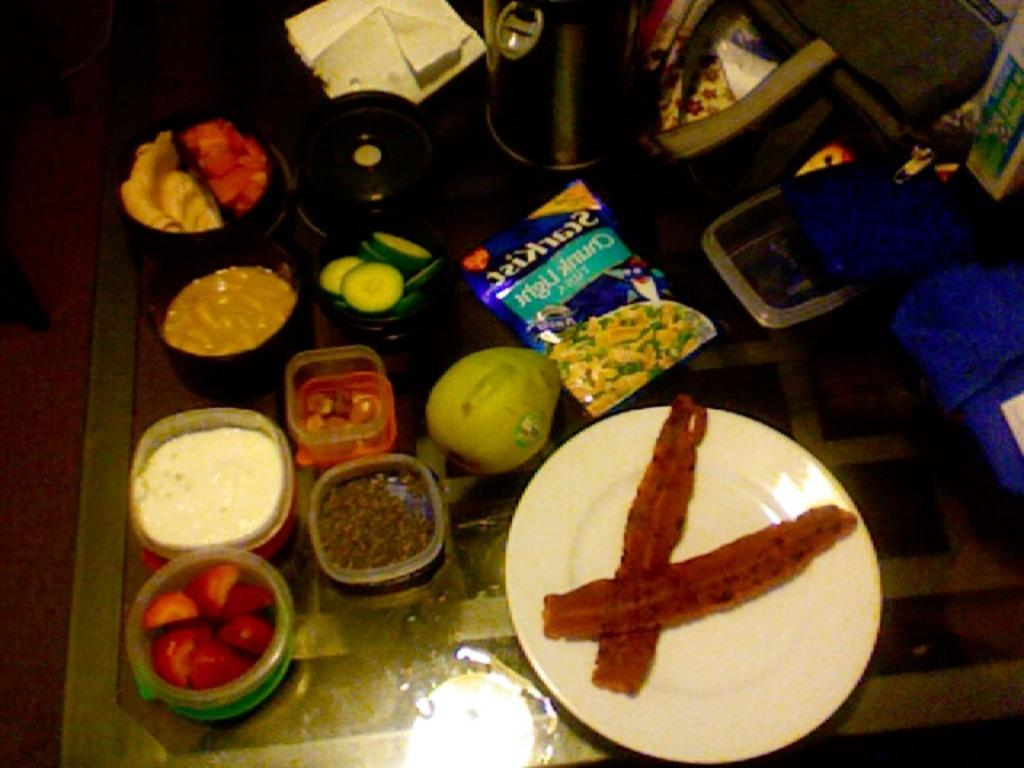What is the main subject in the center of the image? There are foods in the center of the image. Where are the foods located? The foods are on a table. What color are the objects on the right side of the image? The objects on the right side of the image are blue. What can be seen on the top of the image? There is a flask and a paper on the top of the image. How many dust particles can be seen on the sweater in the image? There is no sweater present in the image, and therefore no dust particles can be observed. 